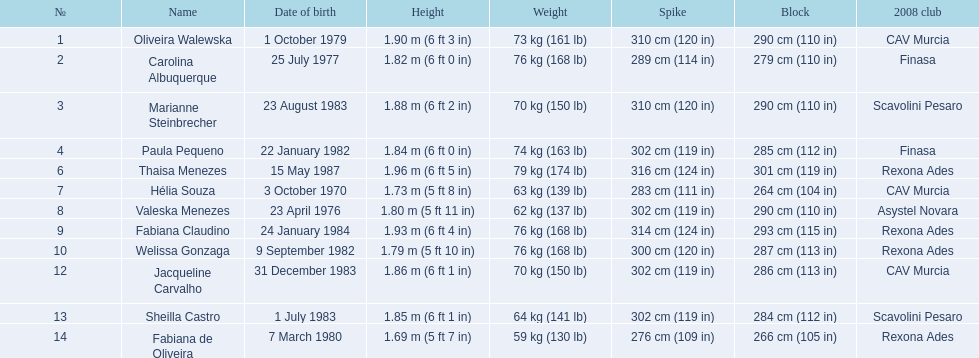What are the elevations of the players? 1.90 m (6 ft 3 in), 1.82 m (6 ft 0 in), 1.88 m (6 ft 2 in), 1.84 m (6 ft 0 in), 1.96 m (6 ft 5 in), 1.73 m (5 ft 8 in), 1.80 m (5 ft 11 in), 1.93 m (6 ft 4 in), 1.79 m (5 ft 10 in), 1.86 m (6 ft 1 in), 1.85 m (6 ft 1 in), 1.69 m (5 ft 7 in). Which of these elevations is the smallest? 1.69 m (5 ft 7 in). Which player is 5'7 tall? Fabiana de Oliveira. 